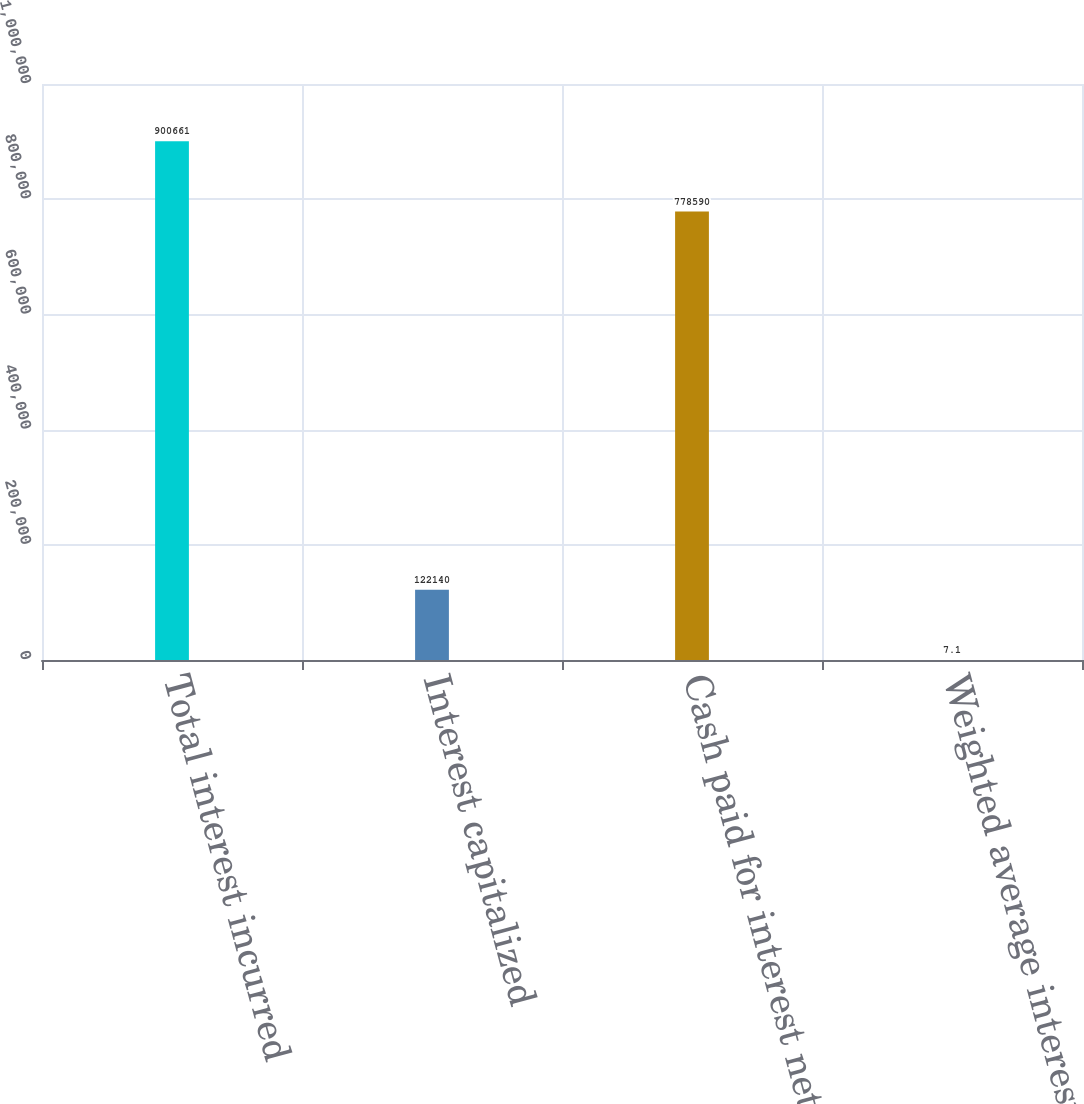<chart> <loc_0><loc_0><loc_500><loc_500><bar_chart><fcel>Total interest incurred<fcel>Interest capitalized<fcel>Cash paid for interest net of<fcel>Weighted average interest rate<nl><fcel>900661<fcel>122140<fcel>778590<fcel>7.1<nl></chart> 